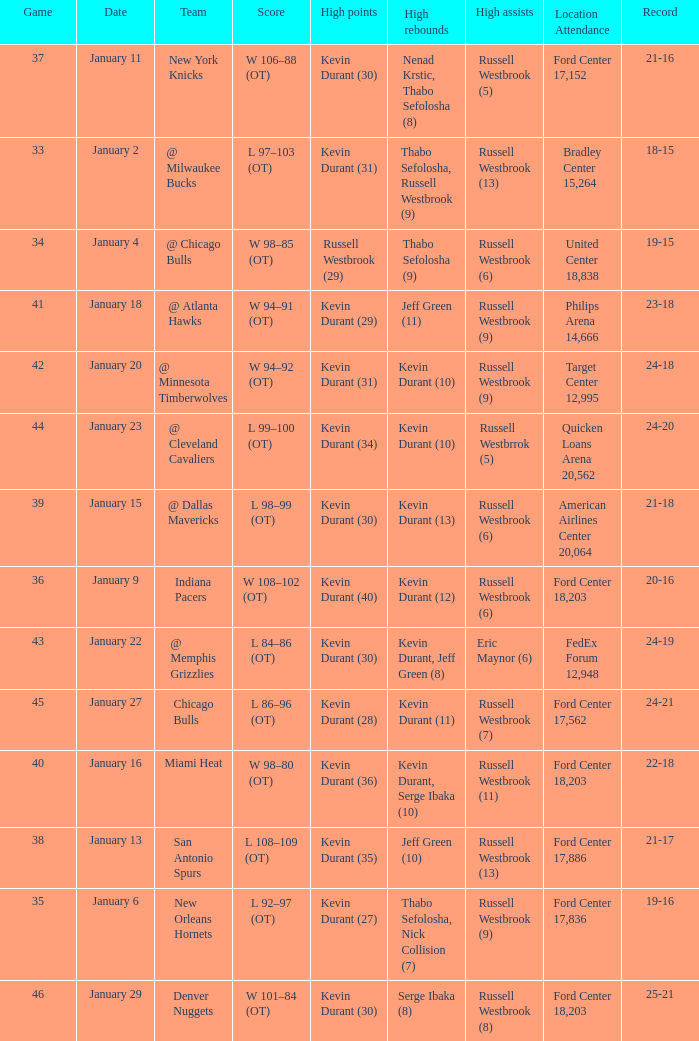Write the full table. {'header': ['Game', 'Date', 'Team', 'Score', 'High points', 'High rebounds', 'High assists', 'Location Attendance', 'Record'], 'rows': [['37', 'January 11', 'New York Knicks', 'W 106–88 (OT)', 'Kevin Durant (30)', 'Nenad Krstic, Thabo Sefolosha (8)', 'Russell Westbrook (5)', 'Ford Center 17,152', '21-16'], ['33', 'January 2', '@ Milwaukee Bucks', 'L 97–103 (OT)', 'Kevin Durant (31)', 'Thabo Sefolosha, Russell Westbrook (9)', 'Russell Westbrook (13)', 'Bradley Center 15,264', '18-15'], ['34', 'January 4', '@ Chicago Bulls', 'W 98–85 (OT)', 'Russell Westbrook (29)', 'Thabo Sefolosha (9)', 'Russell Westbrook (6)', 'United Center 18,838', '19-15'], ['41', 'January 18', '@ Atlanta Hawks', 'W 94–91 (OT)', 'Kevin Durant (29)', 'Jeff Green (11)', 'Russell Westbrook (9)', 'Philips Arena 14,666', '23-18'], ['42', 'January 20', '@ Minnesota Timberwolves', 'W 94–92 (OT)', 'Kevin Durant (31)', 'Kevin Durant (10)', 'Russell Westbrook (9)', 'Target Center 12,995', '24-18'], ['44', 'January 23', '@ Cleveland Cavaliers', 'L 99–100 (OT)', 'Kevin Durant (34)', 'Kevin Durant (10)', 'Russell Westbrrok (5)', 'Quicken Loans Arena 20,562', '24-20'], ['39', 'January 15', '@ Dallas Mavericks', 'L 98–99 (OT)', 'Kevin Durant (30)', 'Kevin Durant (13)', 'Russell Westbrook (6)', 'American Airlines Center 20,064', '21-18'], ['36', 'January 9', 'Indiana Pacers', 'W 108–102 (OT)', 'Kevin Durant (40)', 'Kevin Durant (12)', 'Russell Westbrook (6)', 'Ford Center 18,203', '20-16'], ['43', 'January 22', '@ Memphis Grizzlies', 'L 84–86 (OT)', 'Kevin Durant (30)', 'Kevin Durant, Jeff Green (8)', 'Eric Maynor (6)', 'FedEx Forum 12,948', '24-19'], ['45', 'January 27', 'Chicago Bulls', 'L 86–96 (OT)', 'Kevin Durant (28)', 'Kevin Durant (11)', 'Russell Westbrook (7)', 'Ford Center 17,562', '24-21'], ['40', 'January 16', 'Miami Heat', 'W 98–80 (OT)', 'Kevin Durant (36)', 'Kevin Durant, Serge Ibaka (10)', 'Russell Westbrook (11)', 'Ford Center 18,203', '22-18'], ['38', 'January 13', 'San Antonio Spurs', 'L 108–109 (OT)', 'Kevin Durant (35)', 'Jeff Green (10)', 'Russell Westbrook (13)', 'Ford Center 17,886', '21-17'], ['35', 'January 6', 'New Orleans Hornets', 'L 92–97 (OT)', 'Kevin Durant (27)', 'Thabo Sefolosha, Nick Collision (7)', 'Russell Westbrook (9)', 'Ford Center 17,836', '19-16'], ['46', 'January 29', 'Denver Nuggets', 'W 101–84 (OT)', 'Kevin Durant (30)', 'Serge Ibaka (8)', 'Russell Westbrook (8)', 'Ford Center 18,203', '25-21']]} Name the team for january 4 @ Chicago Bulls. 